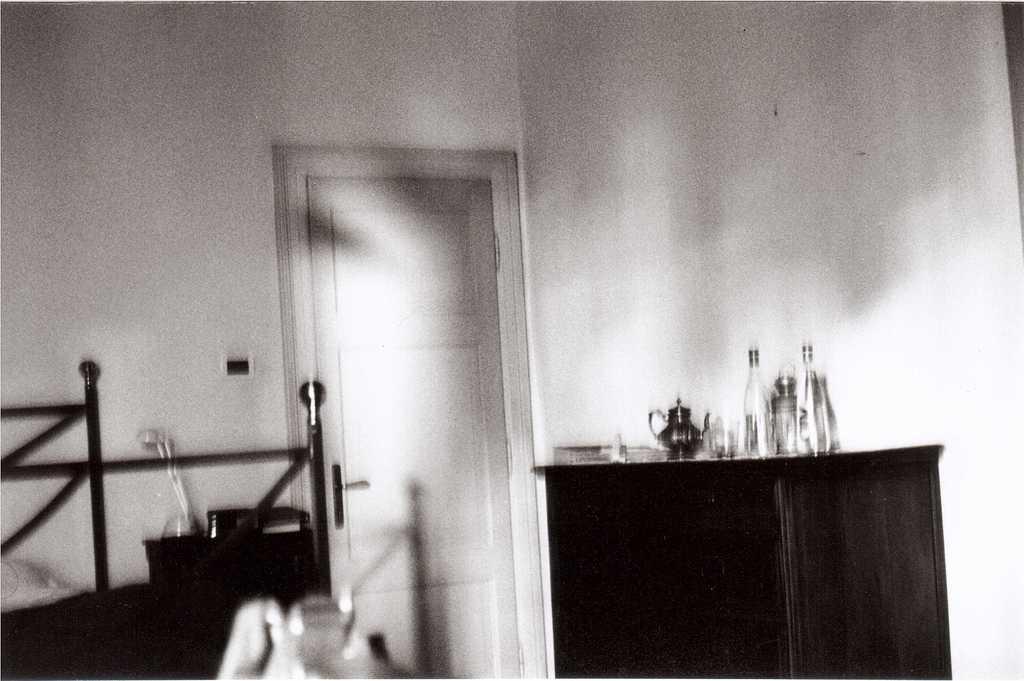How would you summarize this image in a sentence or two? This picture describes about inside view of a room, in this we can find few bottles and other things on the table. 